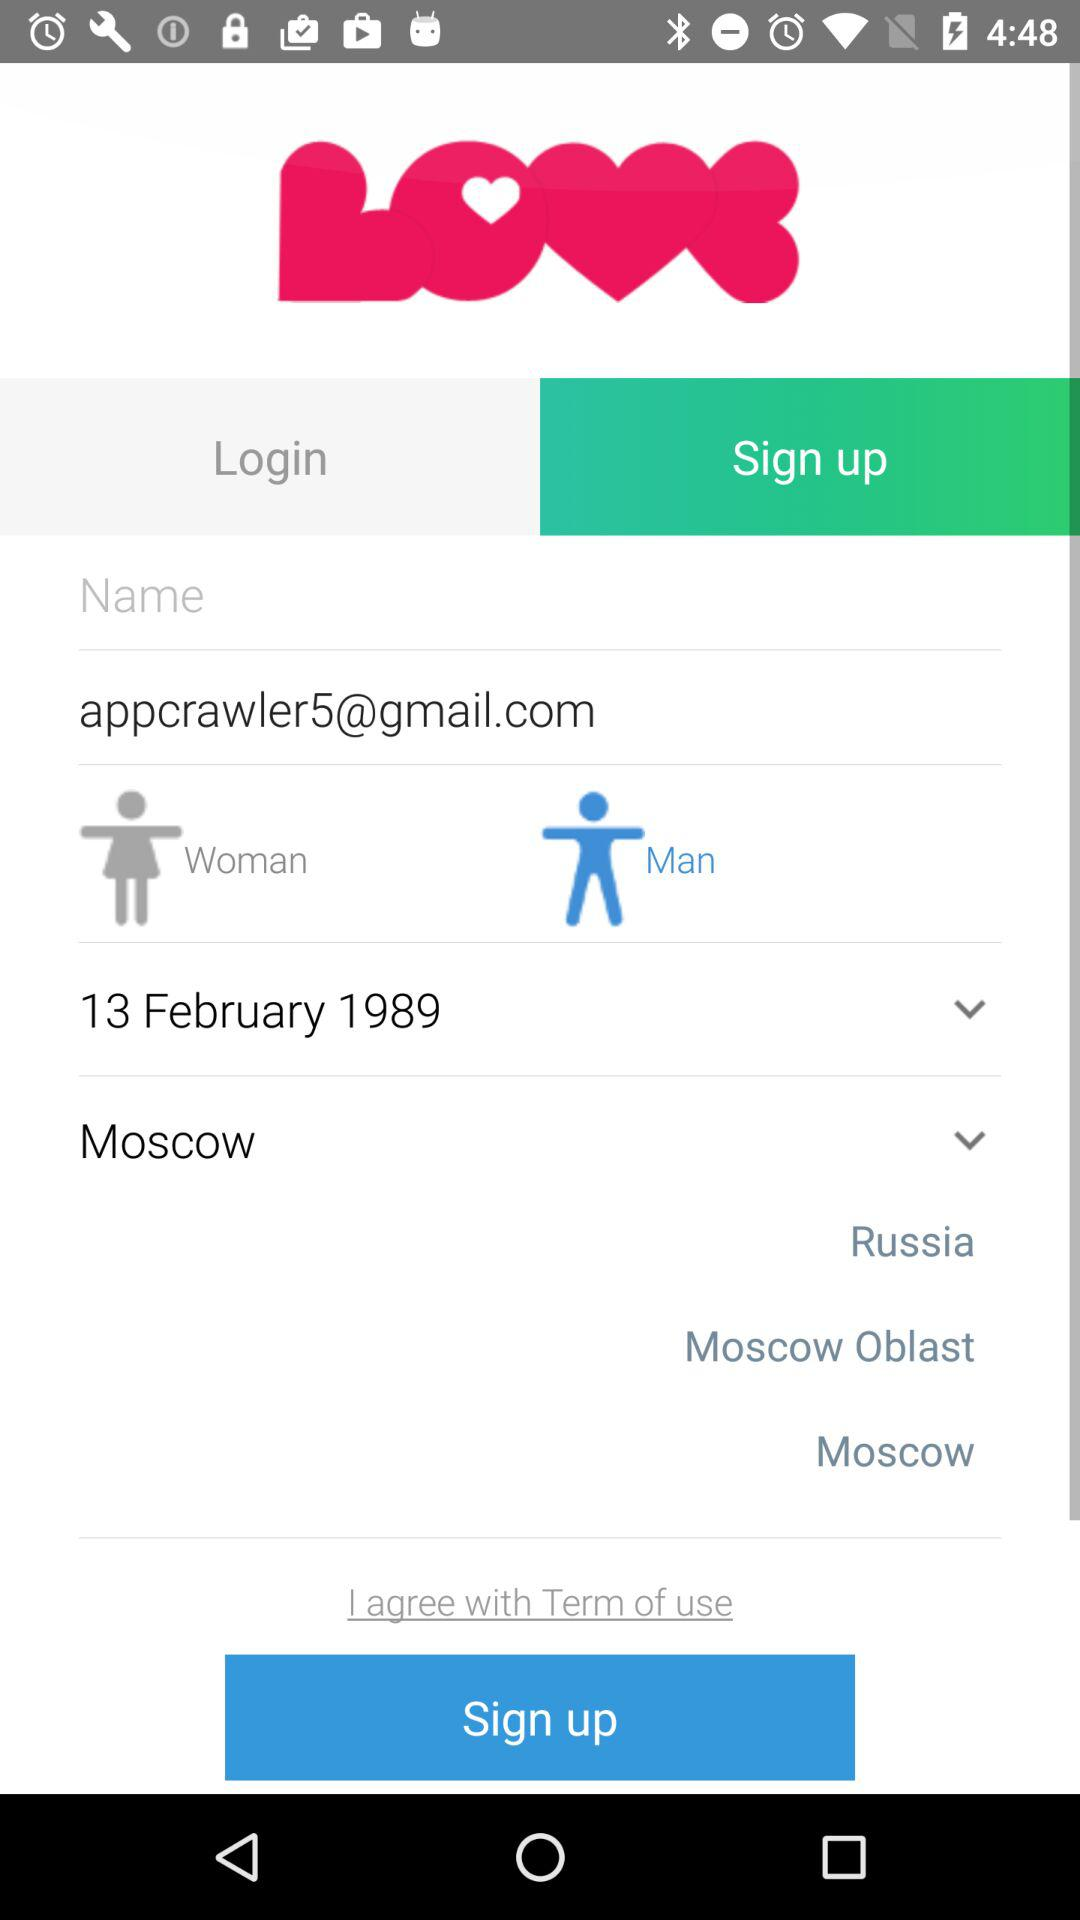What is the application name? The application name is "LOVE". 